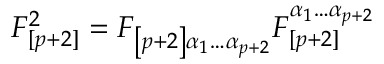<formula> <loc_0><loc_0><loc_500><loc_500>F _ { [ p + 2 ] } ^ { 2 } = F _ { \left [ p + 2 \right ] \alpha _ { 1 } \dots \alpha _ { p + 2 } } F _ { [ p + 2 ] } ^ { \alpha _ { 1 } \dots \alpha _ { p + 2 } }</formula> 